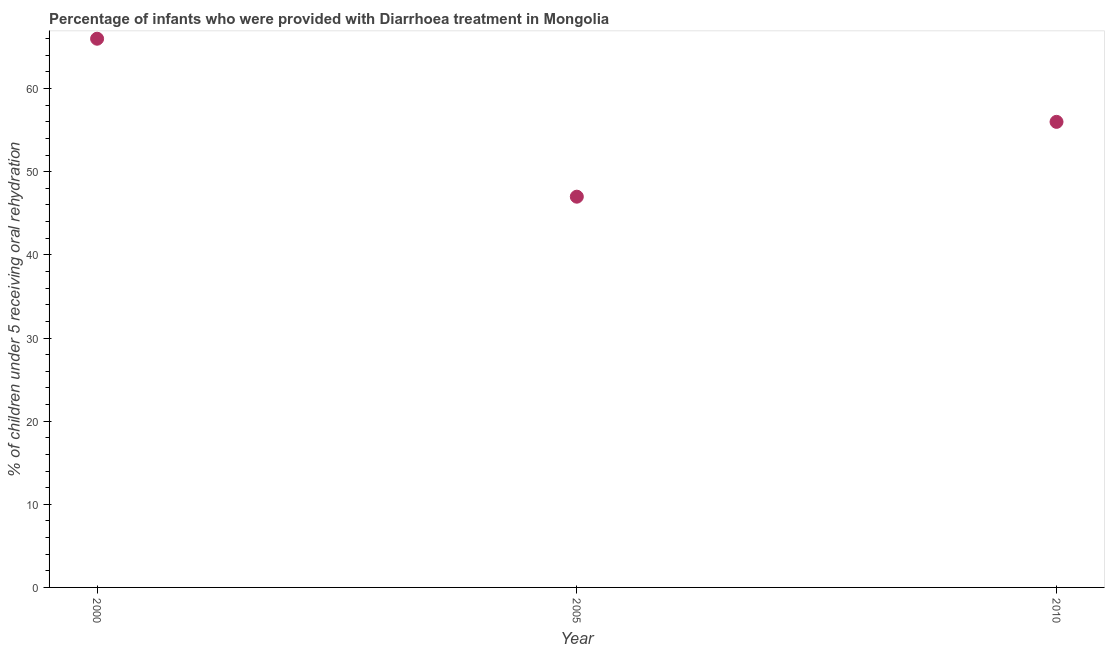What is the percentage of children who were provided with treatment diarrhoea in 2000?
Offer a very short reply. 66. Across all years, what is the maximum percentage of children who were provided with treatment diarrhoea?
Ensure brevity in your answer.  66. Across all years, what is the minimum percentage of children who were provided with treatment diarrhoea?
Ensure brevity in your answer.  47. In which year was the percentage of children who were provided with treatment diarrhoea maximum?
Give a very brief answer. 2000. What is the sum of the percentage of children who were provided with treatment diarrhoea?
Your answer should be compact. 169. What is the difference between the percentage of children who were provided with treatment diarrhoea in 2005 and 2010?
Your answer should be very brief. -9. What is the average percentage of children who were provided with treatment diarrhoea per year?
Your response must be concise. 56.33. What is the median percentage of children who were provided with treatment diarrhoea?
Keep it short and to the point. 56. In how many years, is the percentage of children who were provided with treatment diarrhoea greater than 48 %?
Ensure brevity in your answer.  2. Do a majority of the years between 2000 and 2010 (inclusive) have percentage of children who were provided with treatment diarrhoea greater than 6 %?
Give a very brief answer. Yes. What is the ratio of the percentage of children who were provided with treatment diarrhoea in 2005 to that in 2010?
Give a very brief answer. 0.84. Is the percentage of children who were provided with treatment diarrhoea in 2000 less than that in 2010?
Make the answer very short. No. Is the difference between the percentage of children who were provided with treatment diarrhoea in 2000 and 2010 greater than the difference between any two years?
Give a very brief answer. No. What is the difference between the highest and the second highest percentage of children who were provided with treatment diarrhoea?
Keep it short and to the point. 10. Is the sum of the percentage of children who were provided with treatment diarrhoea in 2000 and 2010 greater than the maximum percentage of children who were provided with treatment diarrhoea across all years?
Keep it short and to the point. Yes. What is the difference between the highest and the lowest percentage of children who were provided with treatment diarrhoea?
Make the answer very short. 19. In how many years, is the percentage of children who were provided with treatment diarrhoea greater than the average percentage of children who were provided with treatment diarrhoea taken over all years?
Offer a very short reply. 1. How many dotlines are there?
Make the answer very short. 1. Are the values on the major ticks of Y-axis written in scientific E-notation?
Your answer should be compact. No. Does the graph contain any zero values?
Provide a succinct answer. No. What is the title of the graph?
Your answer should be very brief. Percentage of infants who were provided with Diarrhoea treatment in Mongolia. What is the label or title of the X-axis?
Your answer should be compact. Year. What is the label or title of the Y-axis?
Your answer should be very brief. % of children under 5 receiving oral rehydration. What is the % of children under 5 receiving oral rehydration in 2000?
Keep it short and to the point. 66. What is the % of children under 5 receiving oral rehydration in 2005?
Make the answer very short. 47. What is the % of children under 5 receiving oral rehydration in 2010?
Make the answer very short. 56. What is the difference between the % of children under 5 receiving oral rehydration in 2000 and 2005?
Ensure brevity in your answer.  19. What is the difference between the % of children under 5 receiving oral rehydration in 2005 and 2010?
Give a very brief answer. -9. What is the ratio of the % of children under 5 receiving oral rehydration in 2000 to that in 2005?
Your response must be concise. 1.4. What is the ratio of the % of children under 5 receiving oral rehydration in 2000 to that in 2010?
Provide a short and direct response. 1.18. What is the ratio of the % of children under 5 receiving oral rehydration in 2005 to that in 2010?
Make the answer very short. 0.84. 